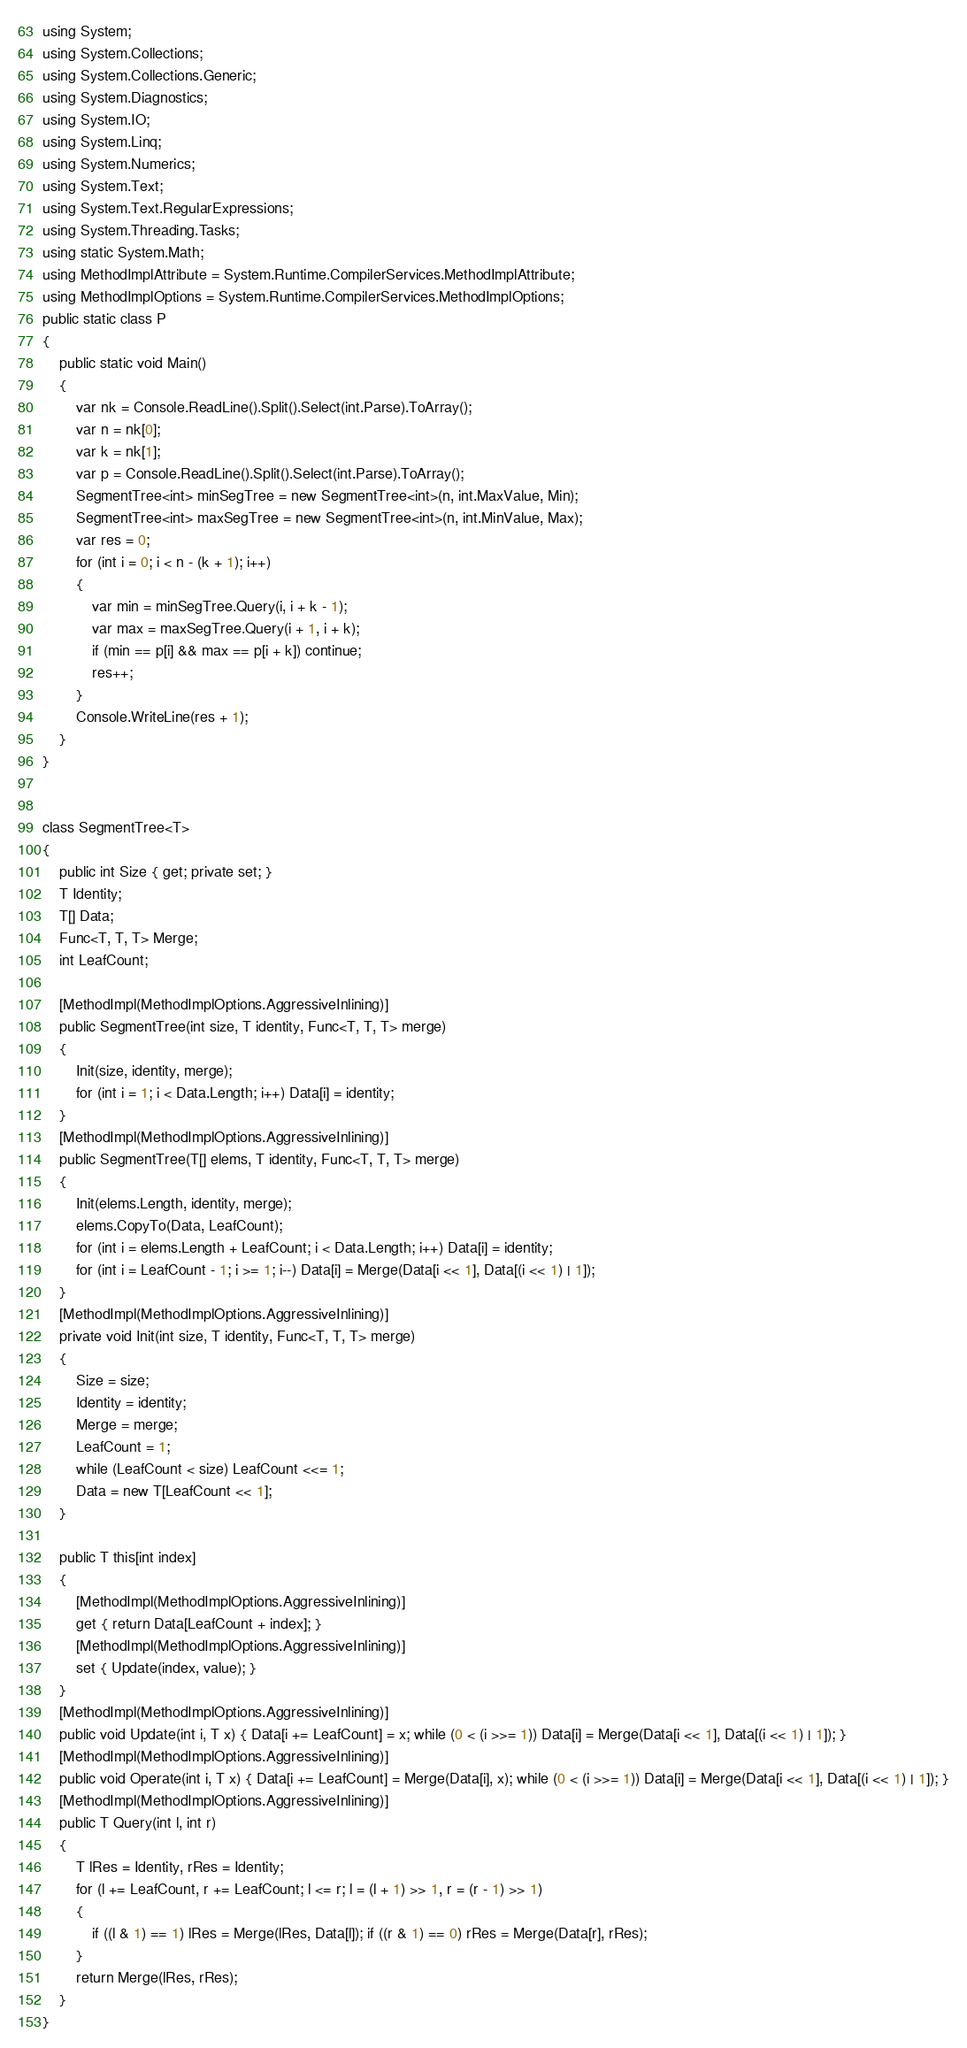<code> <loc_0><loc_0><loc_500><loc_500><_C#_>using System;
using System.Collections;
using System.Collections.Generic;
using System.Diagnostics;
using System.IO;
using System.Linq;
using System.Numerics;
using System.Text;
using System.Text.RegularExpressions;
using System.Threading.Tasks;
using static System.Math;
using MethodImplAttribute = System.Runtime.CompilerServices.MethodImplAttribute;
using MethodImplOptions = System.Runtime.CompilerServices.MethodImplOptions;
public static class P
{
    public static void Main()
    {
        var nk = Console.ReadLine().Split().Select(int.Parse).ToArray();
        var n = nk[0];
        var k = nk[1];
        var p = Console.ReadLine().Split().Select(int.Parse).ToArray();
        SegmentTree<int> minSegTree = new SegmentTree<int>(n, int.MaxValue, Min);
        SegmentTree<int> maxSegTree = new SegmentTree<int>(n, int.MinValue, Max);
        var res = 0;
        for (int i = 0; i < n - (k + 1); i++)
        {
            var min = minSegTree.Query(i, i + k - 1);
            var max = maxSegTree.Query(i + 1, i + k);
            if (min == p[i] && max == p[i + k]) continue;
            res++;
        }
        Console.WriteLine(res + 1);
    }
}


class SegmentTree<T>
{
    public int Size { get; private set; }
    T Identity;
    T[] Data;
    Func<T, T, T> Merge;
    int LeafCount;

    [MethodImpl(MethodImplOptions.AggressiveInlining)]
    public SegmentTree(int size, T identity, Func<T, T, T> merge)
    {
        Init(size, identity, merge);
        for (int i = 1; i < Data.Length; i++) Data[i] = identity;
    }
    [MethodImpl(MethodImplOptions.AggressiveInlining)]
    public SegmentTree(T[] elems, T identity, Func<T, T, T> merge)
    {
        Init(elems.Length, identity, merge);
        elems.CopyTo(Data, LeafCount);
        for (int i = elems.Length + LeafCount; i < Data.Length; i++) Data[i] = identity;
        for (int i = LeafCount - 1; i >= 1; i--) Data[i] = Merge(Data[i << 1], Data[(i << 1) | 1]);
    }
    [MethodImpl(MethodImplOptions.AggressiveInlining)]
    private void Init(int size, T identity, Func<T, T, T> merge)
    {
        Size = size;
        Identity = identity;
        Merge = merge;
        LeafCount = 1;
        while (LeafCount < size) LeafCount <<= 1;
        Data = new T[LeafCount << 1];
    }

    public T this[int index]
    {
        [MethodImpl(MethodImplOptions.AggressiveInlining)]
        get { return Data[LeafCount + index]; }
        [MethodImpl(MethodImplOptions.AggressiveInlining)]
        set { Update(index, value); }
    }
    [MethodImpl(MethodImplOptions.AggressiveInlining)]
    public void Update(int i, T x) { Data[i += LeafCount] = x; while (0 < (i >>= 1)) Data[i] = Merge(Data[i << 1], Data[(i << 1) | 1]); }
    [MethodImpl(MethodImplOptions.AggressiveInlining)]
    public void Operate(int i, T x) { Data[i += LeafCount] = Merge(Data[i], x); while (0 < (i >>= 1)) Data[i] = Merge(Data[i << 1], Data[(i << 1) | 1]); }
    [MethodImpl(MethodImplOptions.AggressiveInlining)]
    public T Query(int l, int r)
    {
        T lRes = Identity, rRes = Identity;
        for (l += LeafCount, r += LeafCount; l <= r; l = (l + 1) >> 1, r = (r - 1) >> 1)
        {
            if ((l & 1) == 1) lRes = Merge(lRes, Data[l]); if ((r & 1) == 0) rRes = Merge(Data[r], rRes);
        }
        return Merge(lRes, rRes);
    }
}
</code> 